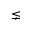Convert formula to latex. <formula><loc_0><loc_0><loc_500><loc_500>\lneq</formula> 